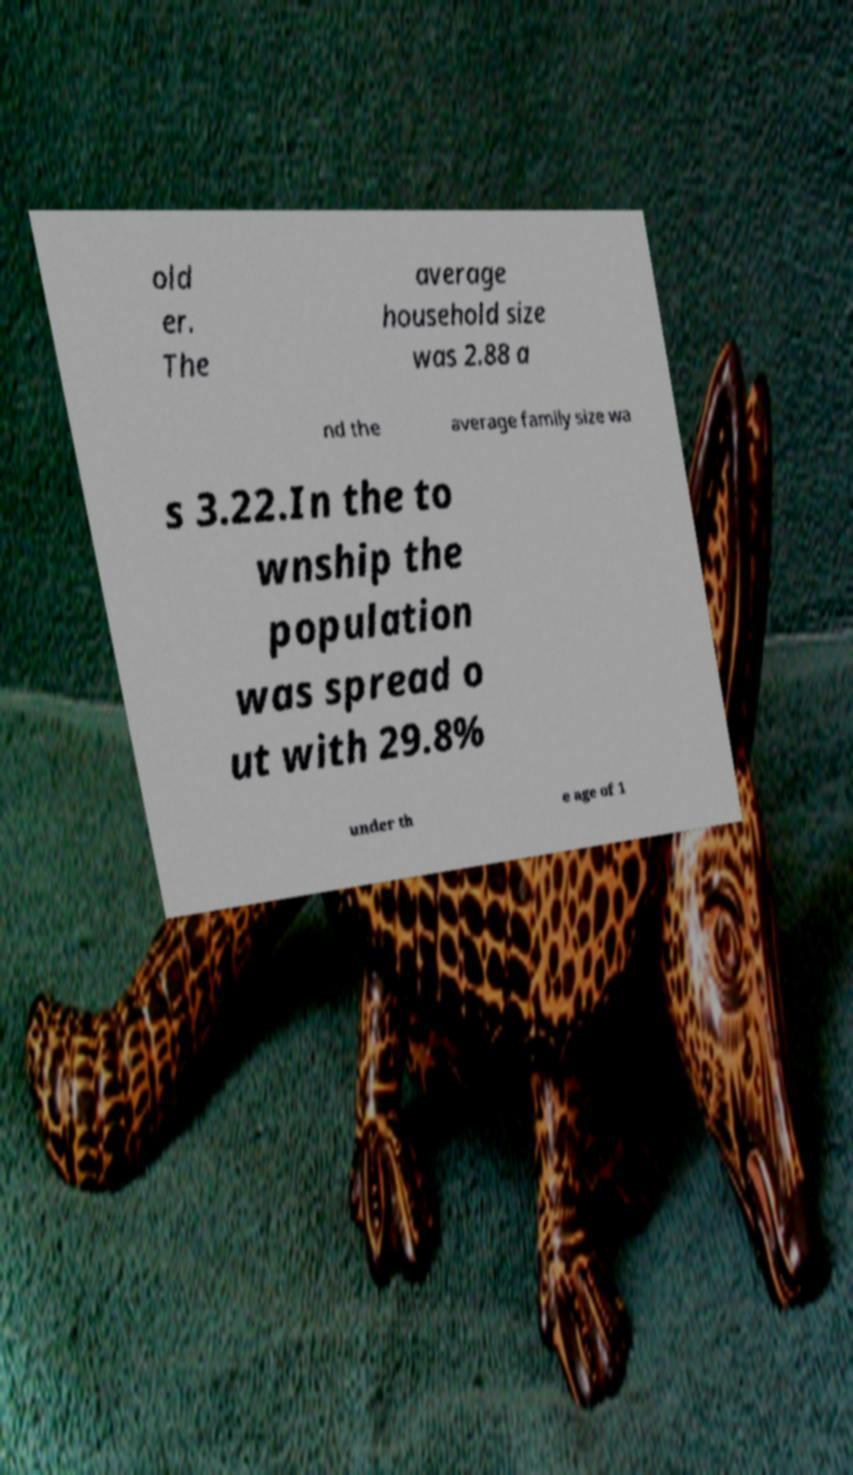Please identify and transcribe the text found in this image. old er. The average household size was 2.88 a nd the average family size wa s 3.22.In the to wnship the population was spread o ut with 29.8% under th e age of 1 